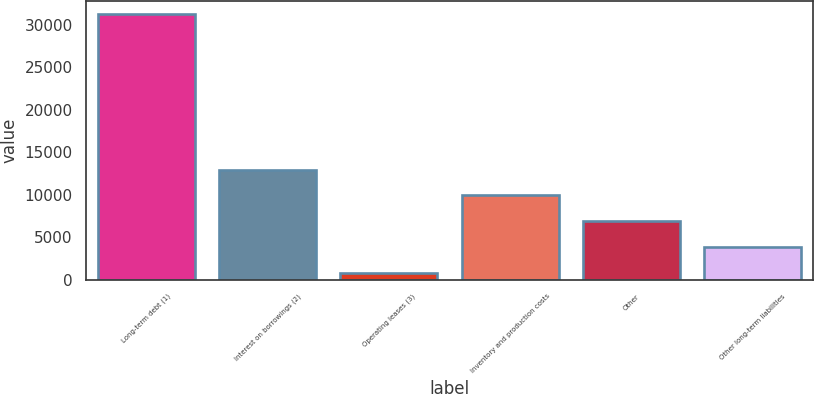Convert chart. <chart><loc_0><loc_0><loc_500><loc_500><bar_chart><fcel>Long-term debt (1)<fcel>Interest on borrowings (2)<fcel>Operating leases (3)<fcel>Inventory and production costs<fcel>Other<fcel>Other long-term liabilities<nl><fcel>31268<fcel>12970.4<fcel>772<fcel>9920.8<fcel>6871.2<fcel>3821.6<nl></chart> 